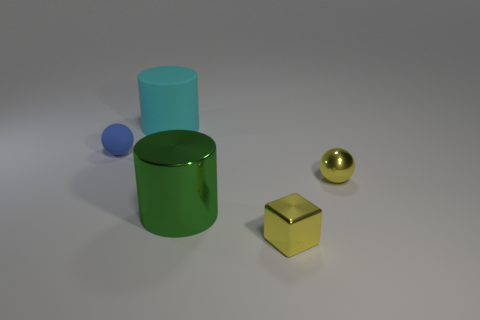Are the sphere that is on the left side of the big metal object and the big object behind the large green metal cylinder made of the same material?
Provide a short and direct response. Yes. What is the material of the cyan thing?
Offer a very short reply. Rubber. Are there more tiny yellow cubes in front of the small blue matte thing than big brown metallic cubes?
Offer a very short reply. Yes. How many small yellow metal spheres are behind the small yellow metallic thing in front of the tiny sphere right of the small blue ball?
Your response must be concise. 1. What material is the small object that is both to the left of the metal sphere and behind the tiny yellow cube?
Your response must be concise. Rubber. What color is the matte cylinder?
Make the answer very short. Cyan. Is the number of blue things behind the big rubber cylinder greater than the number of small balls that are left of the blue rubber ball?
Ensure brevity in your answer.  No. What is the color of the large object behind the green object?
Your answer should be compact. Cyan. There is a thing in front of the big shiny thing; is it the same size as the metal thing on the left side of the cube?
Give a very brief answer. No. How many things are large matte things or green cylinders?
Provide a short and direct response. 2. 